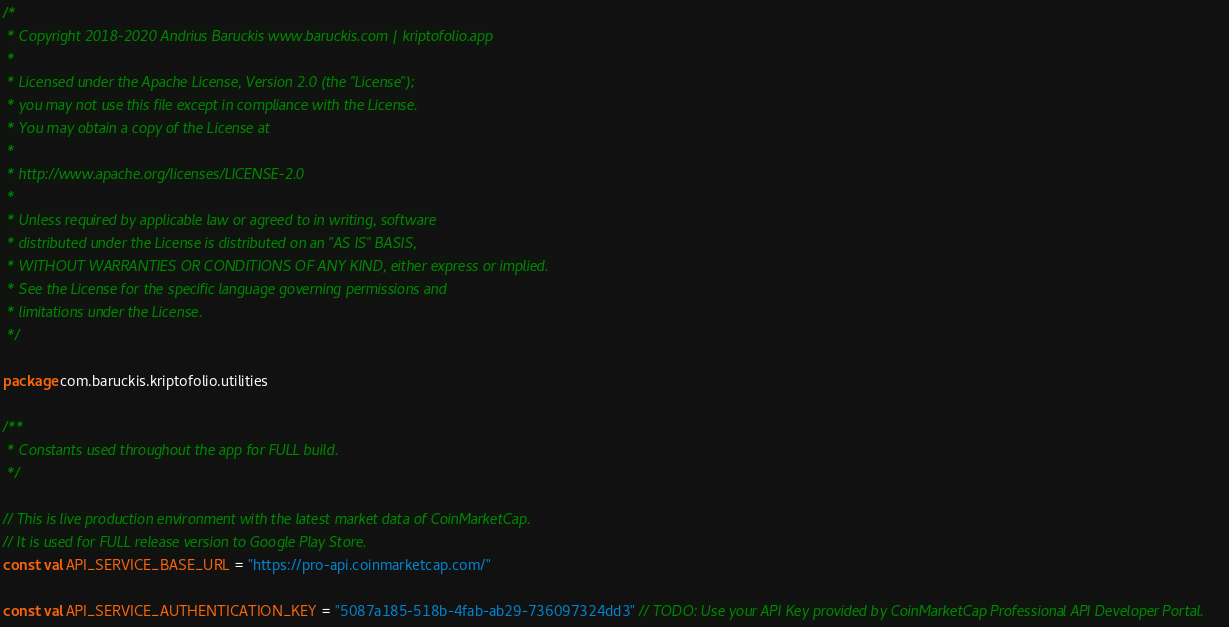Convert code to text. <code><loc_0><loc_0><loc_500><loc_500><_Kotlin_>/*
 * Copyright 2018-2020 Andrius Baruckis www.baruckis.com | kriptofolio.app
 *
 * Licensed under the Apache License, Version 2.0 (the "License");
 * you may not use this file except in compliance with the License.
 * You may obtain a copy of the License at
 *
 * http://www.apache.org/licenses/LICENSE-2.0
 *
 * Unless required by applicable law or agreed to in writing, software
 * distributed under the License is distributed on an "AS IS" BASIS,
 * WITHOUT WARRANTIES OR CONDITIONS OF ANY KIND, either express or implied.
 * See the License for the specific language governing permissions and
 * limitations under the License.
 */

package com.baruckis.kriptofolio.utilities

/**
 * Constants used throughout the app for FULL build.
 */

// This is live production environment with the latest market data of CoinMarketCap.
// It is used for FULL release version to Google Play Store.
const val API_SERVICE_BASE_URL = "https://pro-api.coinmarketcap.com/"

const val API_SERVICE_AUTHENTICATION_KEY = "5087a185-518b-4fab-ab29-736097324dd3" // TODO: Use your API Key provided by CoinMarketCap Professional API Developer Portal.
</code> 